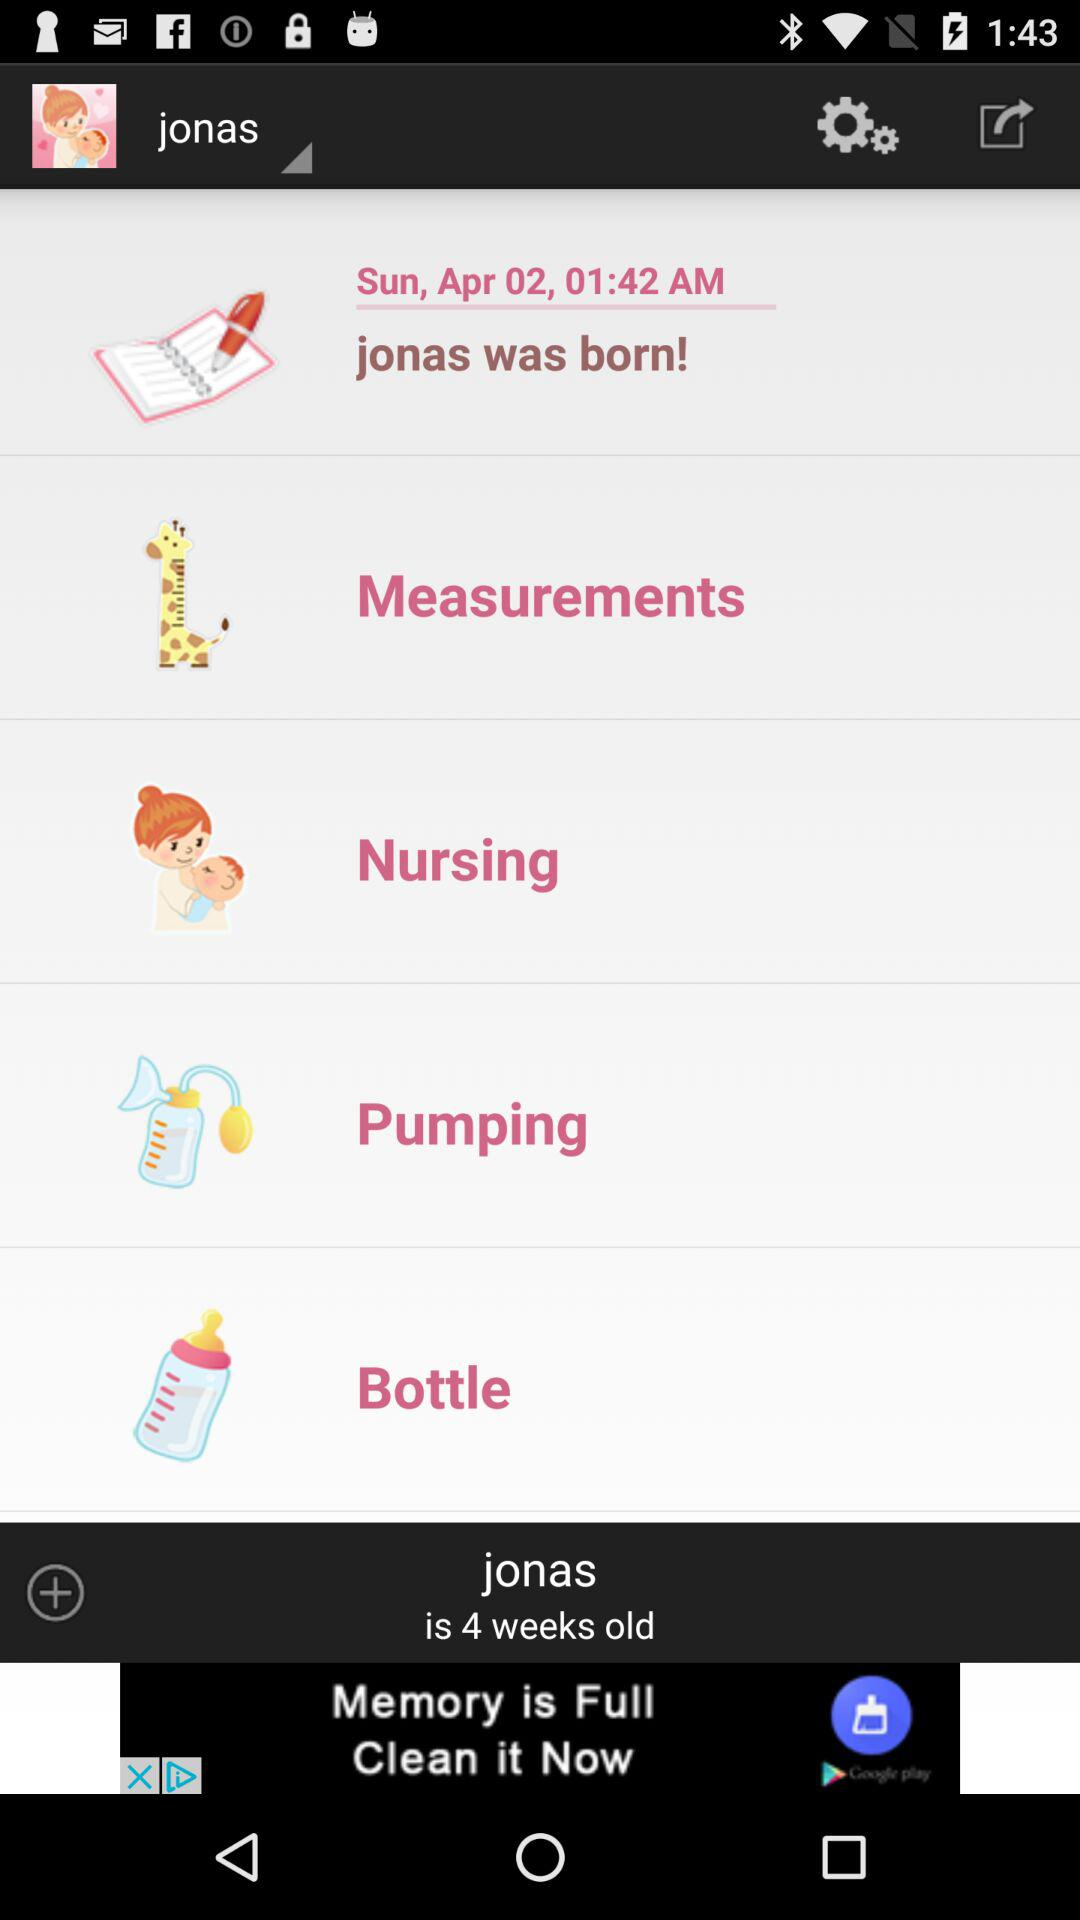When was Jonas born? Jonas was born at 1:42 a.m. on April 2, 2011. 